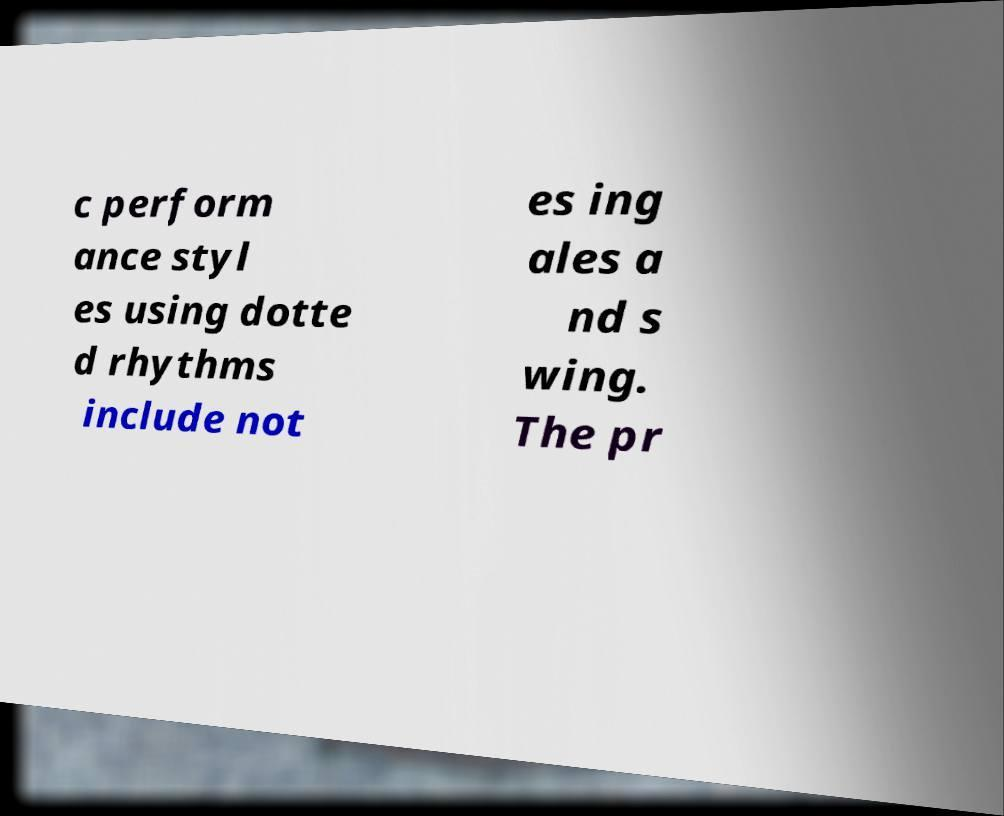For documentation purposes, I need the text within this image transcribed. Could you provide that? c perform ance styl es using dotte d rhythms include not es ing ales a nd s wing. The pr 